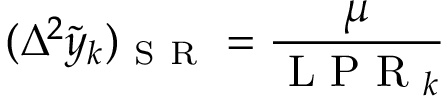Convert formula to latex. <formula><loc_0><loc_0><loc_500><loc_500>( \Delta ^ { 2 } \tilde { y } _ { k } ) _ { S R } = \frac { \mu } { L P R _ { k } }</formula> 